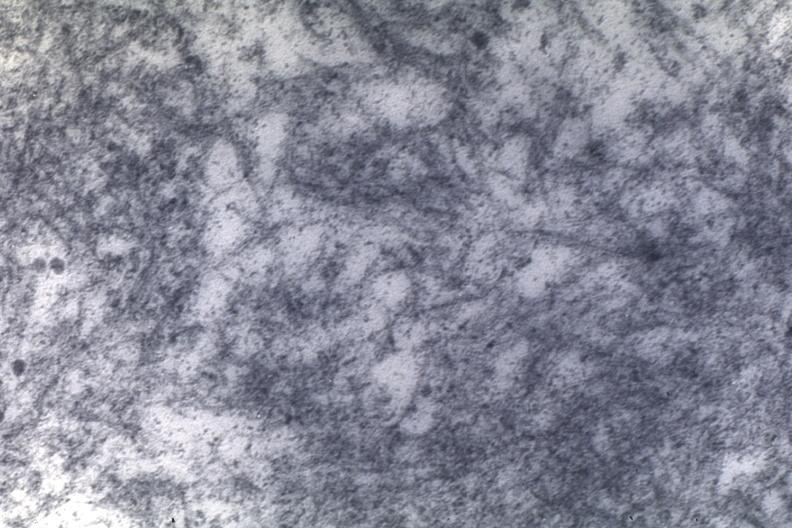what is present?
Answer the question using a single word or phrase. Amyloidosis 